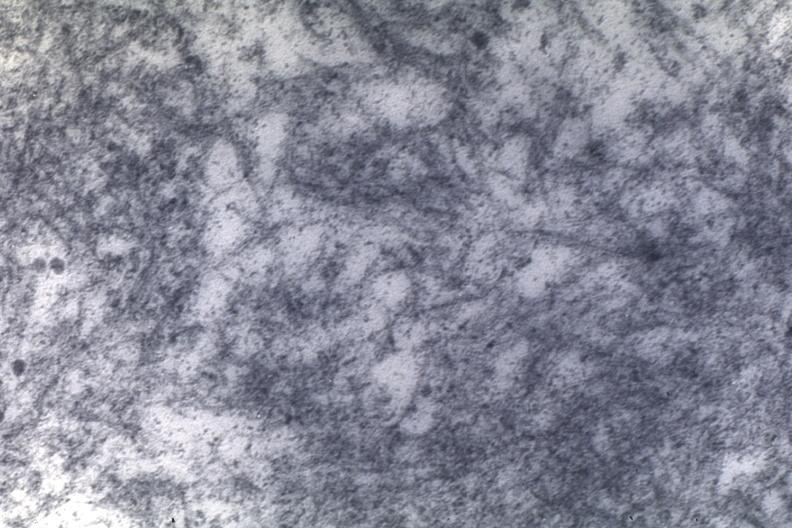what is present?
Answer the question using a single word or phrase. Amyloidosis 